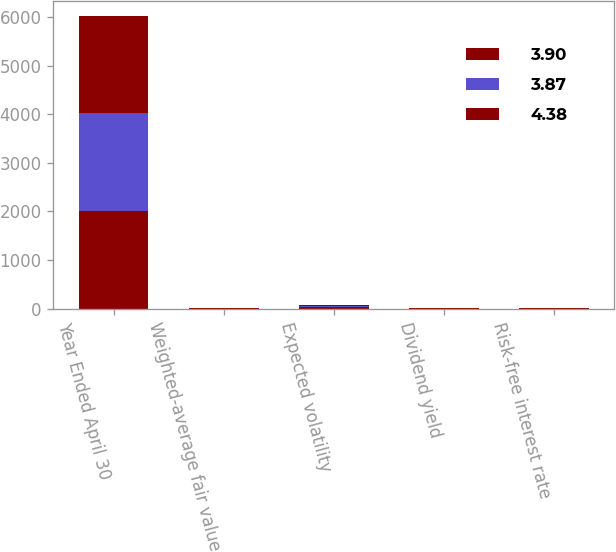Convert chart. <chart><loc_0><loc_0><loc_500><loc_500><stacked_bar_chart><ecel><fcel>Year Ended April 30<fcel>Weighted-average fair value<fcel>Expected volatility<fcel>Dividend yield<fcel>Risk-free interest rate<nl><fcel>3.9<fcel>2009<fcel>3.8<fcel>25.35<fcel>2.8<fcel>2.54<nl><fcel>3.87<fcel>2008<fcel>4.44<fcel>20.75<fcel>2.44<fcel>4.81<nl><fcel>4.38<fcel>2007<fcel>5.15<fcel>20.05<fcel>2.26<fcel>5.11<nl></chart> 